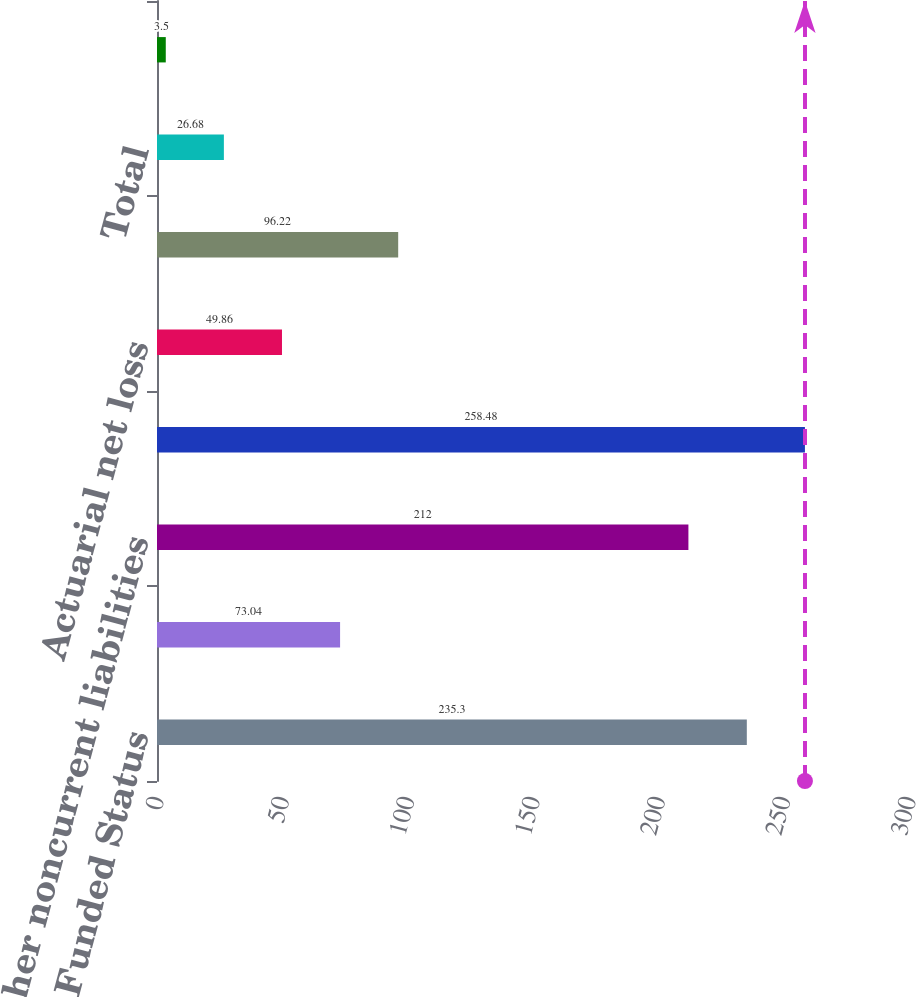Convert chart to OTSL. <chart><loc_0><loc_0><loc_500><loc_500><bar_chart><fcel>Funded Status<fcel>Other accrued liabilities<fcel>Other noncurrent liabilities<fcel>Net Amount Recognized<fcel>Actuarial net loss<fcel>Net prior service cost<fcel>Total<fcel>Discount rate<nl><fcel>235.3<fcel>73.04<fcel>212<fcel>258.48<fcel>49.86<fcel>96.22<fcel>26.68<fcel>3.5<nl></chart> 